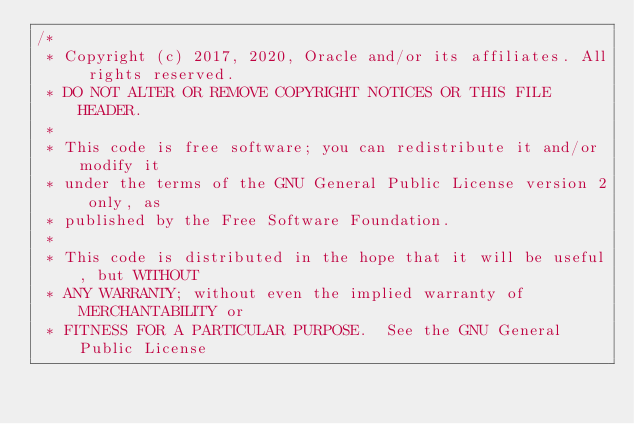Convert code to text. <code><loc_0><loc_0><loc_500><loc_500><_Java_>/*
 * Copyright (c) 2017, 2020, Oracle and/or its affiliates. All rights reserved.
 * DO NOT ALTER OR REMOVE COPYRIGHT NOTICES OR THIS FILE HEADER.
 *
 * This code is free software; you can redistribute it and/or modify it
 * under the terms of the GNU General Public License version 2 only, as
 * published by the Free Software Foundation.
 *
 * This code is distributed in the hope that it will be useful, but WITHOUT
 * ANY WARRANTY; without even the implied warranty of MERCHANTABILITY or
 * FITNESS FOR A PARTICULAR PURPOSE.  See the GNU General Public License</code> 